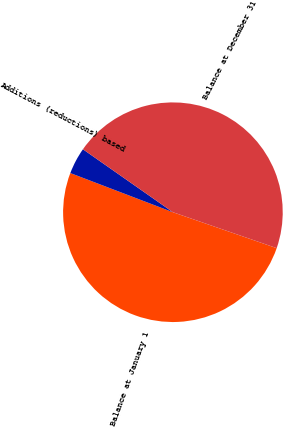<chart> <loc_0><loc_0><loc_500><loc_500><pie_chart><fcel>Balance at January 1<fcel>Additions (reductions) based<fcel>Balance at December 31<nl><fcel>50.5%<fcel>3.91%<fcel>45.59%<nl></chart> 